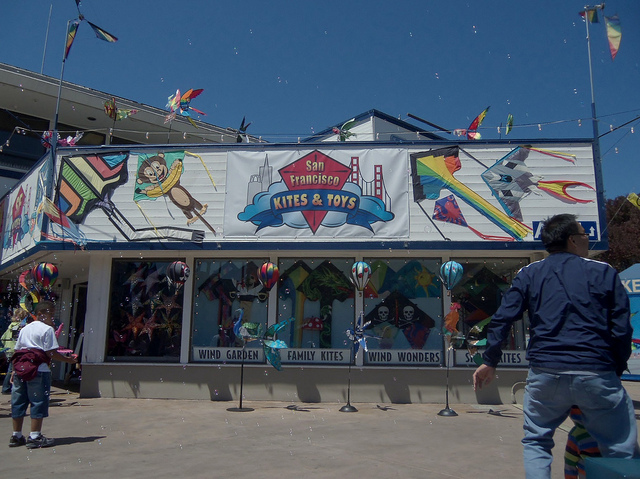<image>What is the color of the girls jacket? It's uncertain what the color of the girl's jacket is. It's mentioned as red, blue, burgundy, and white. The jacket is also mentioned as not visible. What is the color of the girls jacket? It is ambiguous what is the color of the girl's jacket. It can be seen red or white. 